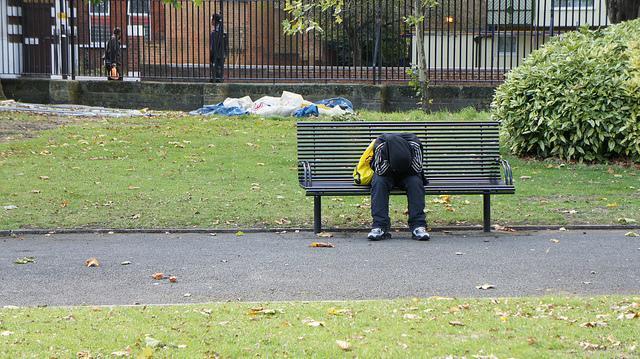How many dogs are running in the surf?
Give a very brief answer. 0. 